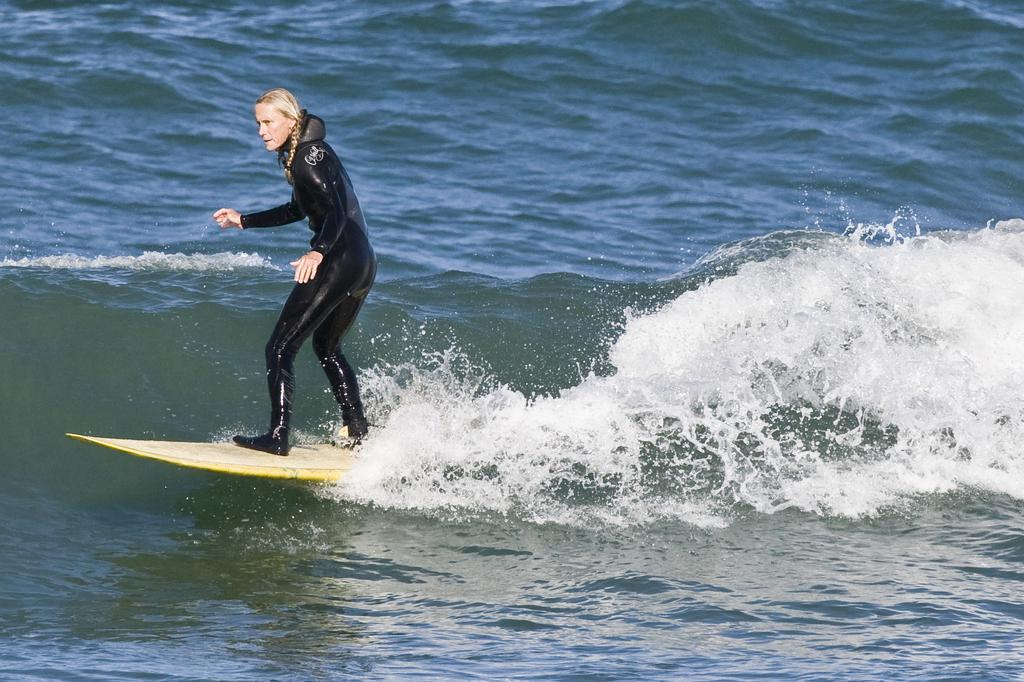Who is the main subject in the image? There is a woman in the image. What is the woman wearing? The woman is wearing a black swimsuit. What activity is the woman engaged in? The woman is surfing. What type of environment is depicted in the image? The image consists of a water body. What type of celery can be seen growing near the woman in the image? There is no celery present in the image; it is a water body where the woman is surfing. 